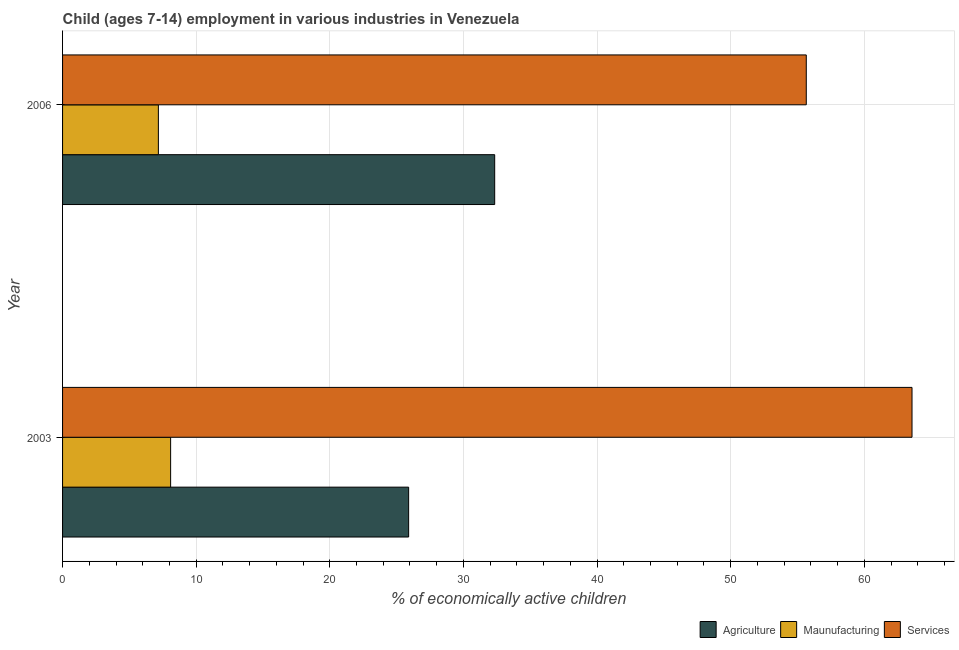How many groups of bars are there?
Provide a succinct answer. 2. Are the number of bars per tick equal to the number of legend labels?
Make the answer very short. Yes. How many bars are there on the 1st tick from the top?
Your answer should be compact. 3. What is the label of the 2nd group of bars from the top?
Ensure brevity in your answer.  2003. In how many cases, is the number of bars for a given year not equal to the number of legend labels?
Your answer should be compact. 0. What is the percentage of economically active children in services in 2006?
Provide a succinct answer. 55.66. Across all years, what is the maximum percentage of economically active children in manufacturing?
Ensure brevity in your answer.  8.09. Across all years, what is the minimum percentage of economically active children in manufacturing?
Your answer should be very brief. 7.17. In which year was the percentage of economically active children in manufacturing maximum?
Offer a very short reply. 2003. In which year was the percentage of economically active children in services minimum?
Make the answer very short. 2006. What is the total percentage of economically active children in services in the graph?
Make the answer very short. 119.23. What is the difference between the percentage of economically active children in agriculture in 2003 and that in 2006?
Offer a very short reply. -6.44. What is the difference between the percentage of economically active children in services in 2006 and the percentage of economically active children in agriculture in 2003?
Provide a succinct answer. 29.76. What is the average percentage of economically active children in agriculture per year?
Offer a very short reply. 29.12. In the year 2003, what is the difference between the percentage of economically active children in agriculture and percentage of economically active children in manufacturing?
Your answer should be compact. 17.81. What is the ratio of the percentage of economically active children in agriculture in 2003 to that in 2006?
Ensure brevity in your answer.  0.8. What does the 2nd bar from the top in 2006 represents?
Give a very brief answer. Maunufacturing. What does the 2nd bar from the bottom in 2003 represents?
Ensure brevity in your answer.  Maunufacturing. How many bars are there?
Provide a short and direct response. 6. How many years are there in the graph?
Provide a short and direct response. 2. Are the values on the major ticks of X-axis written in scientific E-notation?
Make the answer very short. No. Does the graph contain any zero values?
Ensure brevity in your answer.  No. How are the legend labels stacked?
Your response must be concise. Horizontal. What is the title of the graph?
Make the answer very short. Child (ages 7-14) employment in various industries in Venezuela. Does "Solid fuel" appear as one of the legend labels in the graph?
Provide a short and direct response. No. What is the label or title of the X-axis?
Provide a short and direct response. % of economically active children. What is the % of economically active children of Agriculture in 2003?
Provide a succinct answer. 25.9. What is the % of economically active children of Maunufacturing in 2003?
Keep it short and to the point. 8.09. What is the % of economically active children in Services in 2003?
Make the answer very short. 63.57. What is the % of economically active children of Agriculture in 2006?
Offer a very short reply. 32.34. What is the % of economically active children in Maunufacturing in 2006?
Offer a terse response. 7.17. What is the % of economically active children of Services in 2006?
Your answer should be compact. 55.66. Across all years, what is the maximum % of economically active children of Agriculture?
Ensure brevity in your answer.  32.34. Across all years, what is the maximum % of economically active children of Maunufacturing?
Give a very brief answer. 8.09. Across all years, what is the maximum % of economically active children in Services?
Your answer should be very brief. 63.57. Across all years, what is the minimum % of economically active children of Agriculture?
Offer a terse response. 25.9. Across all years, what is the minimum % of economically active children of Maunufacturing?
Provide a succinct answer. 7.17. Across all years, what is the minimum % of economically active children of Services?
Your response must be concise. 55.66. What is the total % of economically active children in Agriculture in the graph?
Keep it short and to the point. 58.24. What is the total % of economically active children of Maunufacturing in the graph?
Offer a terse response. 15.26. What is the total % of economically active children of Services in the graph?
Provide a succinct answer. 119.23. What is the difference between the % of economically active children in Agriculture in 2003 and that in 2006?
Ensure brevity in your answer.  -6.44. What is the difference between the % of economically active children of Maunufacturing in 2003 and that in 2006?
Ensure brevity in your answer.  0.92. What is the difference between the % of economically active children in Services in 2003 and that in 2006?
Your answer should be very brief. 7.91. What is the difference between the % of economically active children in Agriculture in 2003 and the % of economically active children in Maunufacturing in 2006?
Your answer should be compact. 18.73. What is the difference between the % of economically active children in Agriculture in 2003 and the % of economically active children in Services in 2006?
Offer a terse response. -29.76. What is the difference between the % of economically active children of Maunufacturing in 2003 and the % of economically active children of Services in 2006?
Make the answer very short. -47.57. What is the average % of economically active children of Agriculture per year?
Your answer should be compact. 29.12. What is the average % of economically active children of Maunufacturing per year?
Give a very brief answer. 7.63. What is the average % of economically active children in Services per year?
Keep it short and to the point. 59.62. In the year 2003, what is the difference between the % of economically active children of Agriculture and % of economically active children of Maunufacturing?
Provide a succinct answer. 17.81. In the year 2003, what is the difference between the % of economically active children of Agriculture and % of economically active children of Services?
Make the answer very short. -37.67. In the year 2003, what is the difference between the % of economically active children of Maunufacturing and % of economically active children of Services?
Make the answer very short. -55.49. In the year 2006, what is the difference between the % of economically active children of Agriculture and % of economically active children of Maunufacturing?
Make the answer very short. 25.17. In the year 2006, what is the difference between the % of economically active children in Agriculture and % of economically active children in Services?
Offer a terse response. -23.32. In the year 2006, what is the difference between the % of economically active children in Maunufacturing and % of economically active children in Services?
Keep it short and to the point. -48.49. What is the ratio of the % of economically active children in Agriculture in 2003 to that in 2006?
Ensure brevity in your answer.  0.8. What is the ratio of the % of economically active children in Maunufacturing in 2003 to that in 2006?
Your response must be concise. 1.13. What is the ratio of the % of economically active children of Services in 2003 to that in 2006?
Give a very brief answer. 1.14. What is the difference between the highest and the second highest % of economically active children of Agriculture?
Ensure brevity in your answer.  6.44. What is the difference between the highest and the second highest % of economically active children of Maunufacturing?
Your response must be concise. 0.92. What is the difference between the highest and the second highest % of economically active children of Services?
Your answer should be compact. 7.91. What is the difference between the highest and the lowest % of economically active children of Agriculture?
Offer a very short reply. 6.44. What is the difference between the highest and the lowest % of economically active children in Maunufacturing?
Keep it short and to the point. 0.92. What is the difference between the highest and the lowest % of economically active children in Services?
Your answer should be compact. 7.91. 